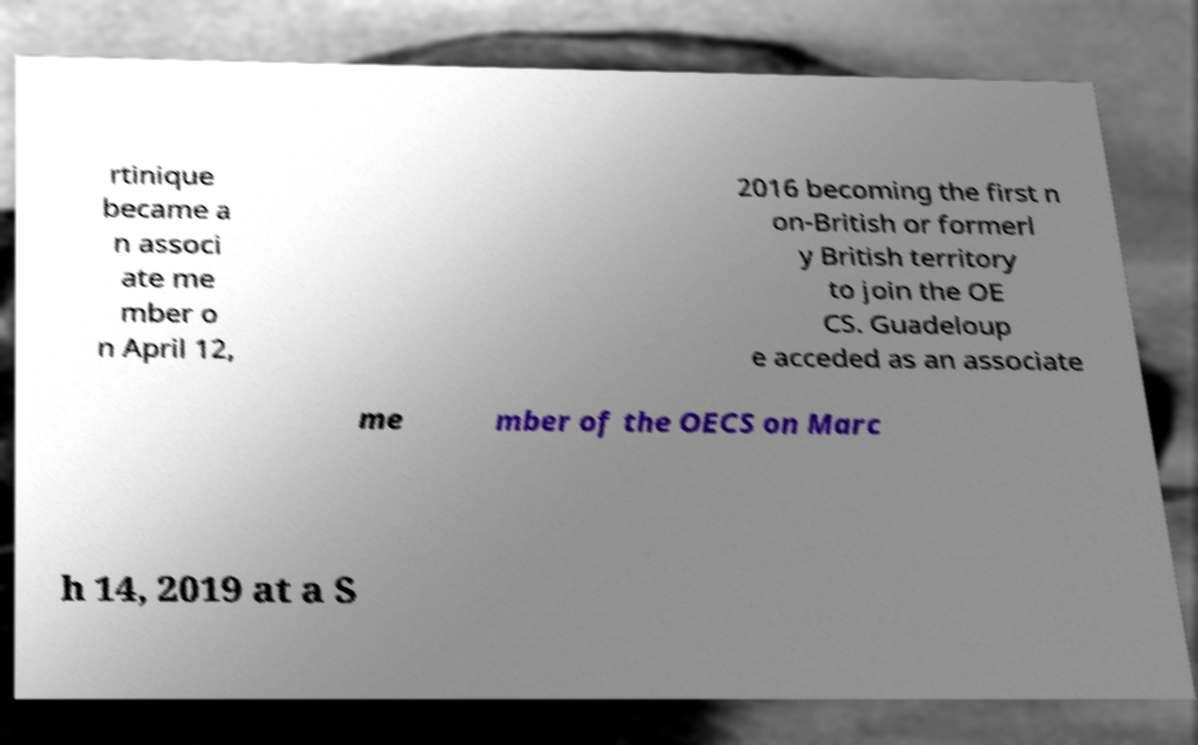Could you assist in decoding the text presented in this image and type it out clearly? rtinique became a n associ ate me mber o n April 12, 2016 becoming the first n on-British or formerl y British territory to join the OE CS. Guadeloup e acceded as an associate me mber of the OECS on Marc h 14, 2019 at a S 